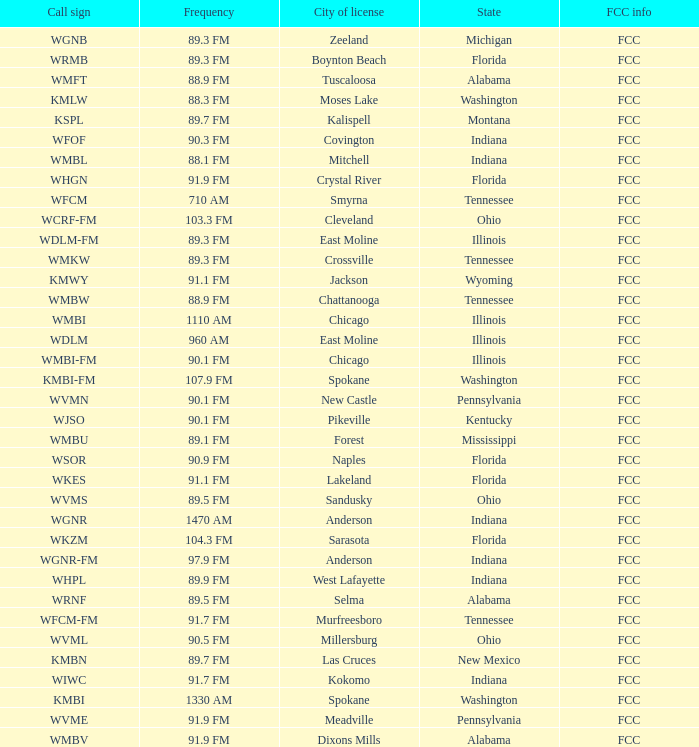What is the call sign for 90.9 FM which is in Florida? WSOR. 